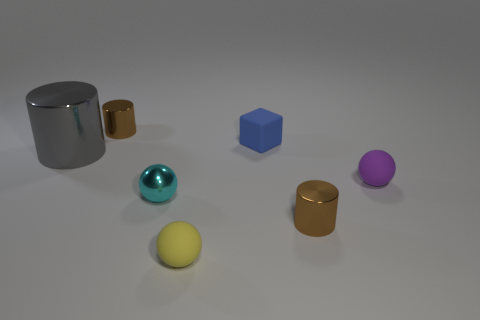Based on the shadows, where do you think the light source is coming from? The shadows in the image extend to the right, suggesting that the light source is situated to the left of the objects. The shadows are soft and diffuse, indicating that either the light source is not extremely close to the objects or it is somewhat large, or perhaps there is a degree of ambient lighting contributing to the scene. 